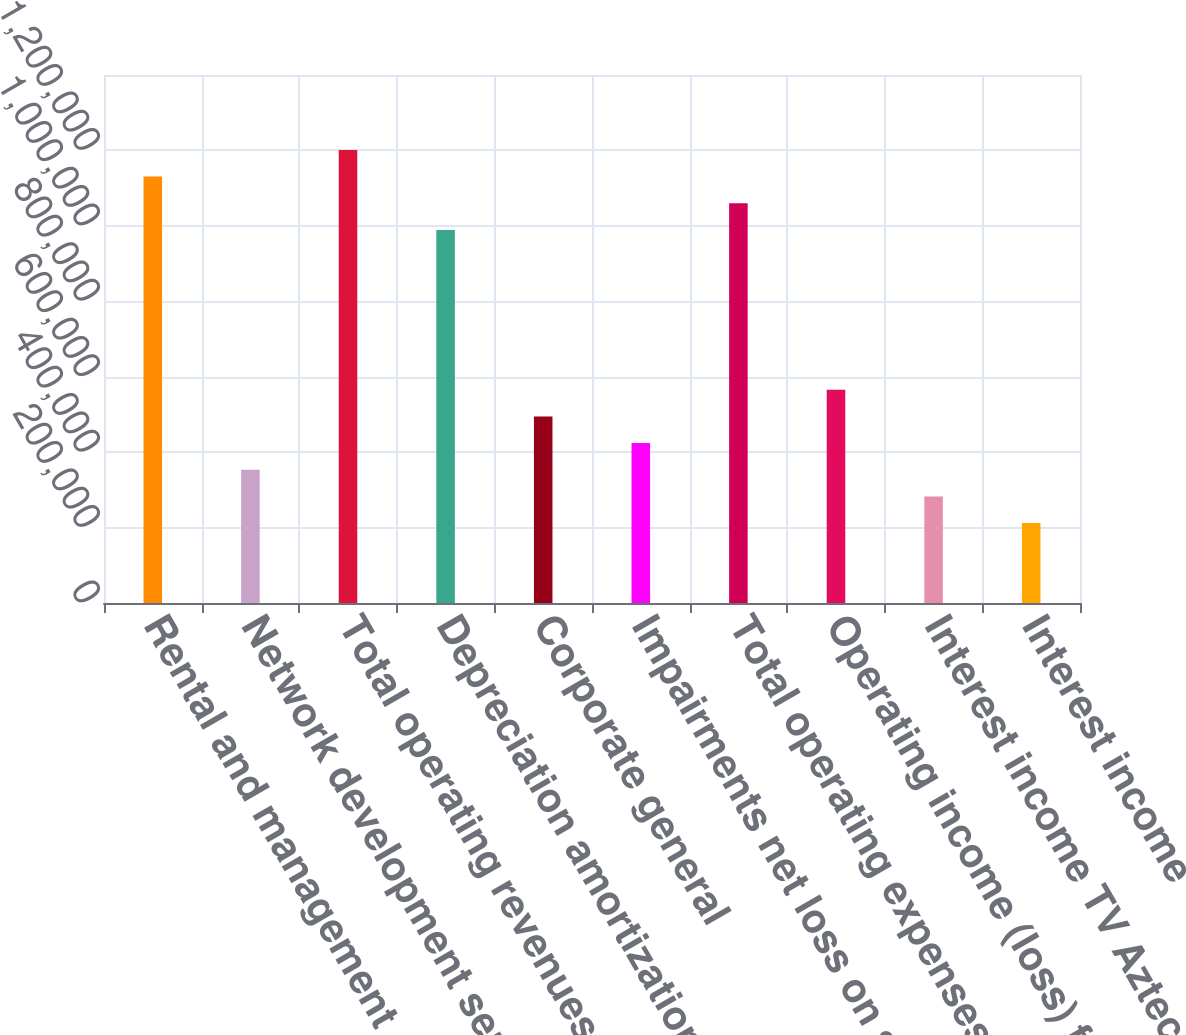<chart> <loc_0><loc_0><loc_500><loc_500><bar_chart><fcel>Rental and management<fcel>Network development services<fcel>Total operating revenues<fcel>Depreciation amortization and<fcel>Corporate general<fcel>Impairments net loss on sale<fcel>Total operating expenses<fcel>Operating income (loss) from<fcel>Interest income TV Azteca net<fcel>Interest income<nl><fcel>1.13066e+06<fcel>353331<fcel>1.20132e+06<fcel>989324<fcel>494662<fcel>423996<fcel>1.05999e+06<fcel>565328<fcel>282665<fcel>211999<nl></chart> 